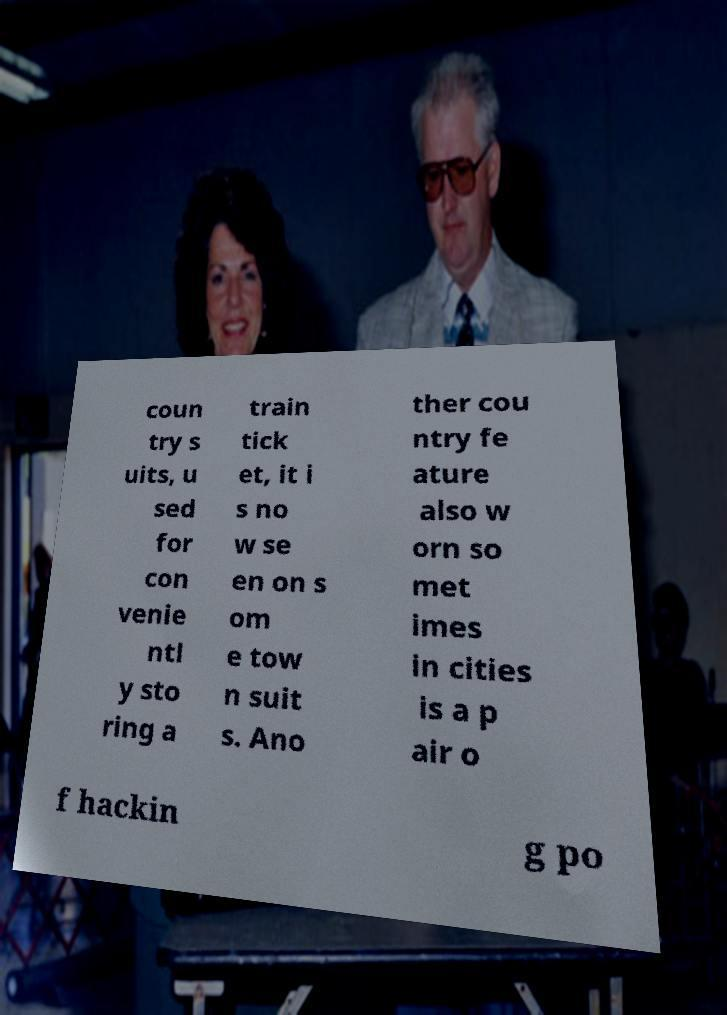Please read and relay the text visible in this image. What does it say? coun try s uits, u sed for con venie ntl y sto ring a train tick et, it i s no w se en on s om e tow n suit s. Ano ther cou ntry fe ature also w orn so met imes in cities is a p air o f hackin g po 